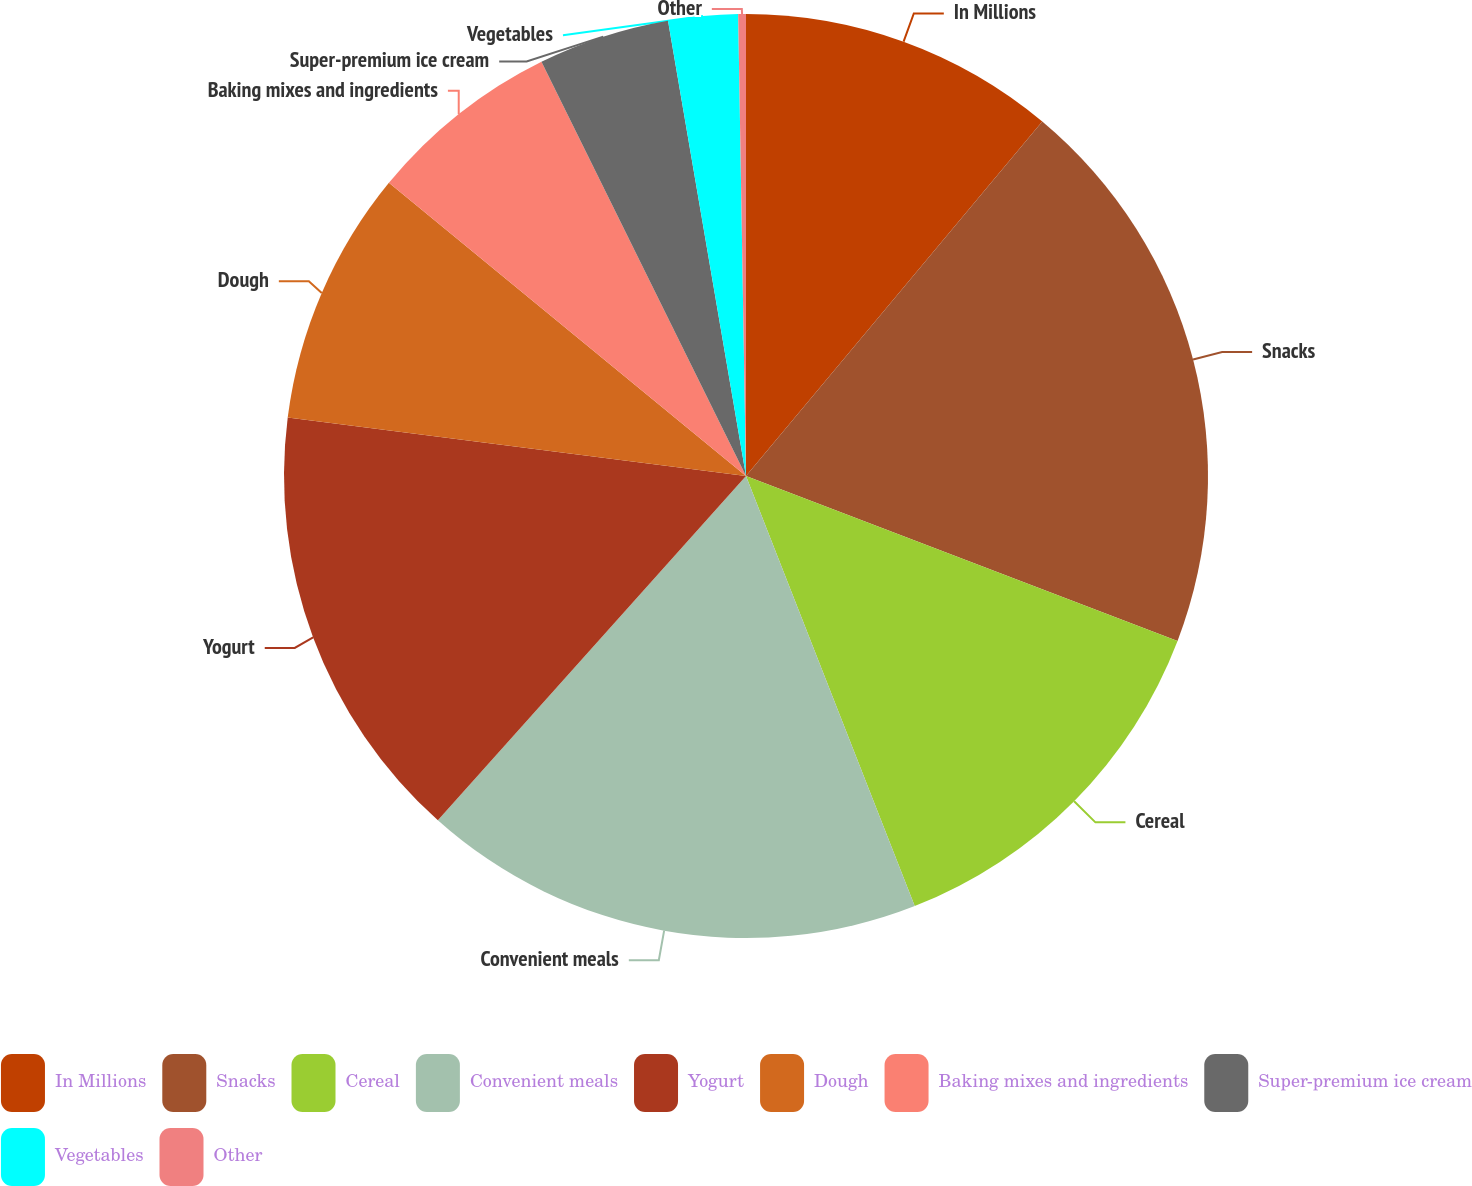Convert chart to OTSL. <chart><loc_0><loc_0><loc_500><loc_500><pie_chart><fcel>In Millions<fcel>Snacks<fcel>Cereal<fcel>Convenient meals<fcel>Yogurt<fcel>Dough<fcel>Baking mixes and ingredients<fcel>Super-premium ice cream<fcel>Vegetables<fcel>Other<nl><fcel>11.08%<fcel>19.73%<fcel>13.24%<fcel>17.57%<fcel>15.4%<fcel>8.92%<fcel>6.76%<fcel>4.6%<fcel>2.43%<fcel>0.27%<nl></chart> 